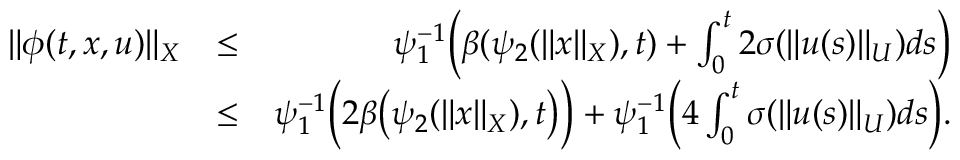<formula> <loc_0><loc_0><loc_500><loc_500>\begin{array} { r l r } { \| \phi ( t , x , u ) \| _ { X } } & { \leq } & { \psi _ { 1 } ^ { - 1 } \left ( \beta ( \psi _ { 2 } ( \| x \| _ { X } ) , t ) + \int _ { 0 } ^ { t } 2 \sigma ( \| u ( s ) \| _ { U } ) d s \right ) } \\ & { \leq } & { \psi _ { 1 } ^ { - 1 } \left ( 2 \beta \left ( \psi _ { 2 } ( \| x \| _ { X } ) , t \right ) \right ) + \psi _ { 1 } ^ { - 1 } \left ( 4 \int _ { 0 } ^ { t } \sigma ( \| u ( s ) \| _ { U } ) d s \right ) . } \end{array}</formula> 